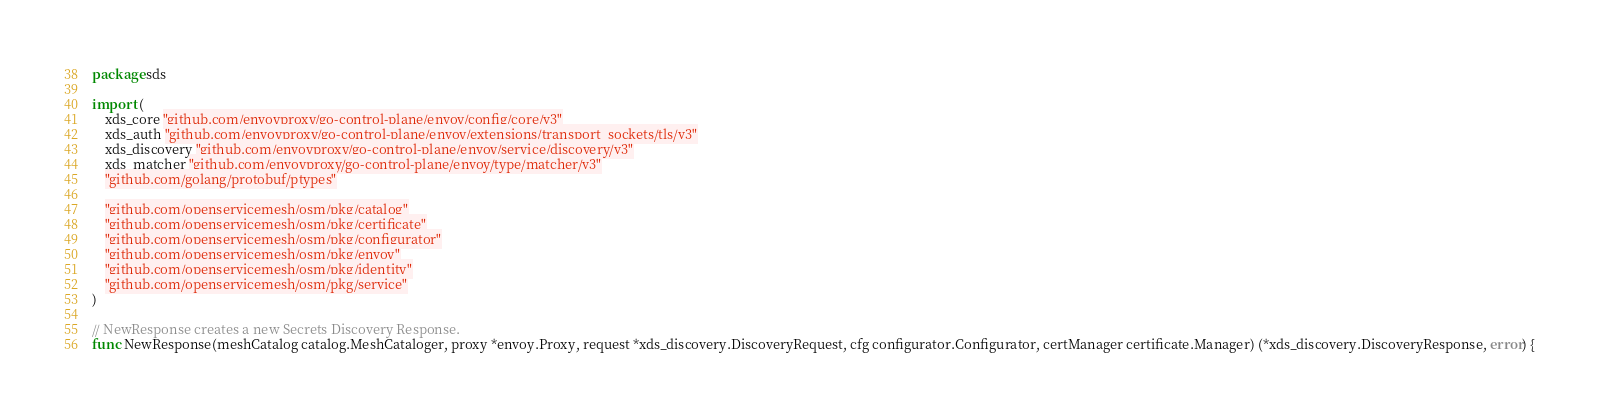Convert code to text. <code><loc_0><loc_0><loc_500><loc_500><_Go_>package sds

import (
	xds_core "github.com/envoyproxy/go-control-plane/envoy/config/core/v3"
	xds_auth "github.com/envoyproxy/go-control-plane/envoy/extensions/transport_sockets/tls/v3"
	xds_discovery "github.com/envoyproxy/go-control-plane/envoy/service/discovery/v3"
	xds_matcher "github.com/envoyproxy/go-control-plane/envoy/type/matcher/v3"
	"github.com/golang/protobuf/ptypes"

	"github.com/openservicemesh/osm/pkg/catalog"
	"github.com/openservicemesh/osm/pkg/certificate"
	"github.com/openservicemesh/osm/pkg/configurator"
	"github.com/openservicemesh/osm/pkg/envoy"
	"github.com/openservicemesh/osm/pkg/identity"
	"github.com/openservicemesh/osm/pkg/service"
)

// NewResponse creates a new Secrets Discovery Response.
func NewResponse(meshCatalog catalog.MeshCataloger, proxy *envoy.Proxy, request *xds_discovery.DiscoveryRequest, cfg configurator.Configurator, certManager certificate.Manager) (*xds_discovery.DiscoveryResponse, error) {</code> 